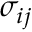<formula> <loc_0><loc_0><loc_500><loc_500>\sigma _ { i j }</formula> 